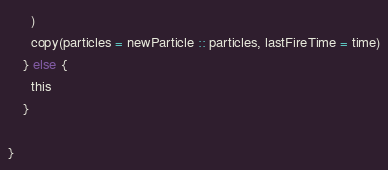<code> <loc_0><loc_0><loc_500><loc_500><_Scala_>      )
      copy(particles = newParticle :: particles, lastFireTime = time)
    } else {
      this
    }

}
</code> 